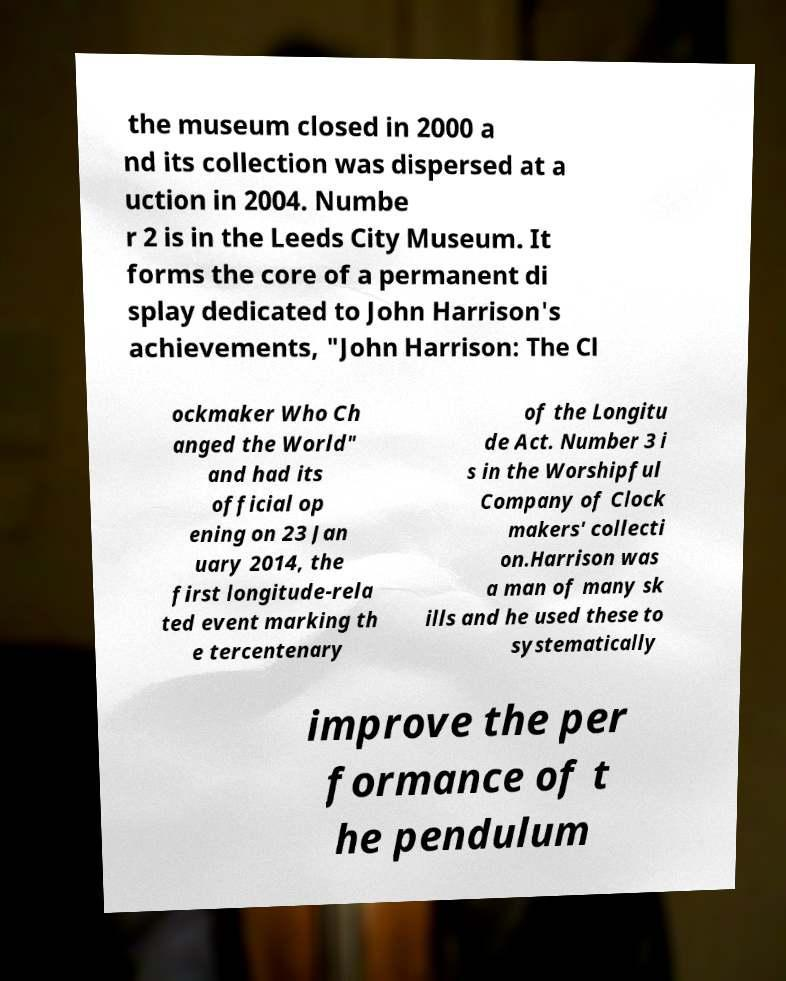What messages or text are displayed in this image? I need them in a readable, typed format. the museum closed in 2000 a nd its collection was dispersed at a uction in 2004. Numbe r 2 is in the Leeds City Museum. It forms the core of a permanent di splay dedicated to John Harrison's achievements, "John Harrison: The Cl ockmaker Who Ch anged the World" and had its official op ening on 23 Jan uary 2014, the first longitude-rela ted event marking th e tercentenary of the Longitu de Act. Number 3 i s in the Worshipful Company of Clock makers' collecti on.Harrison was a man of many sk ills and he used these to systematically improve the per formance of t he pendulum 